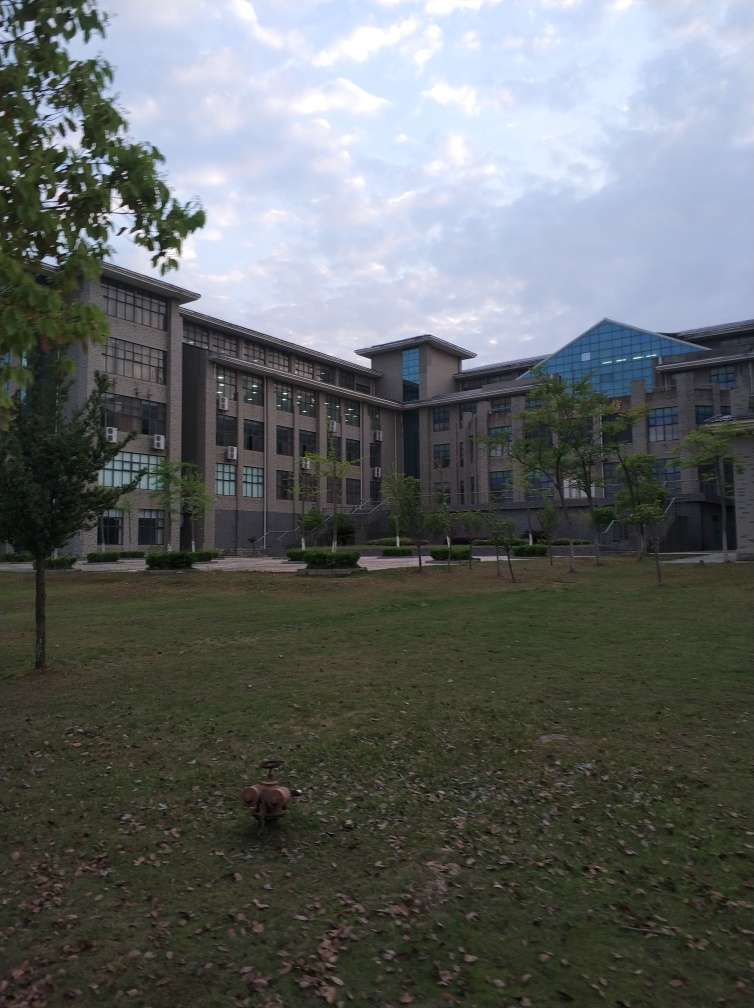What time of day and year does this appear to be? Judging by the image, it appears to be taken during the late afternoon or early evening, given the dim lighting and long shadows cast by the trees. The presence of fallen leaves on the grass suggests that it could be autumn. 